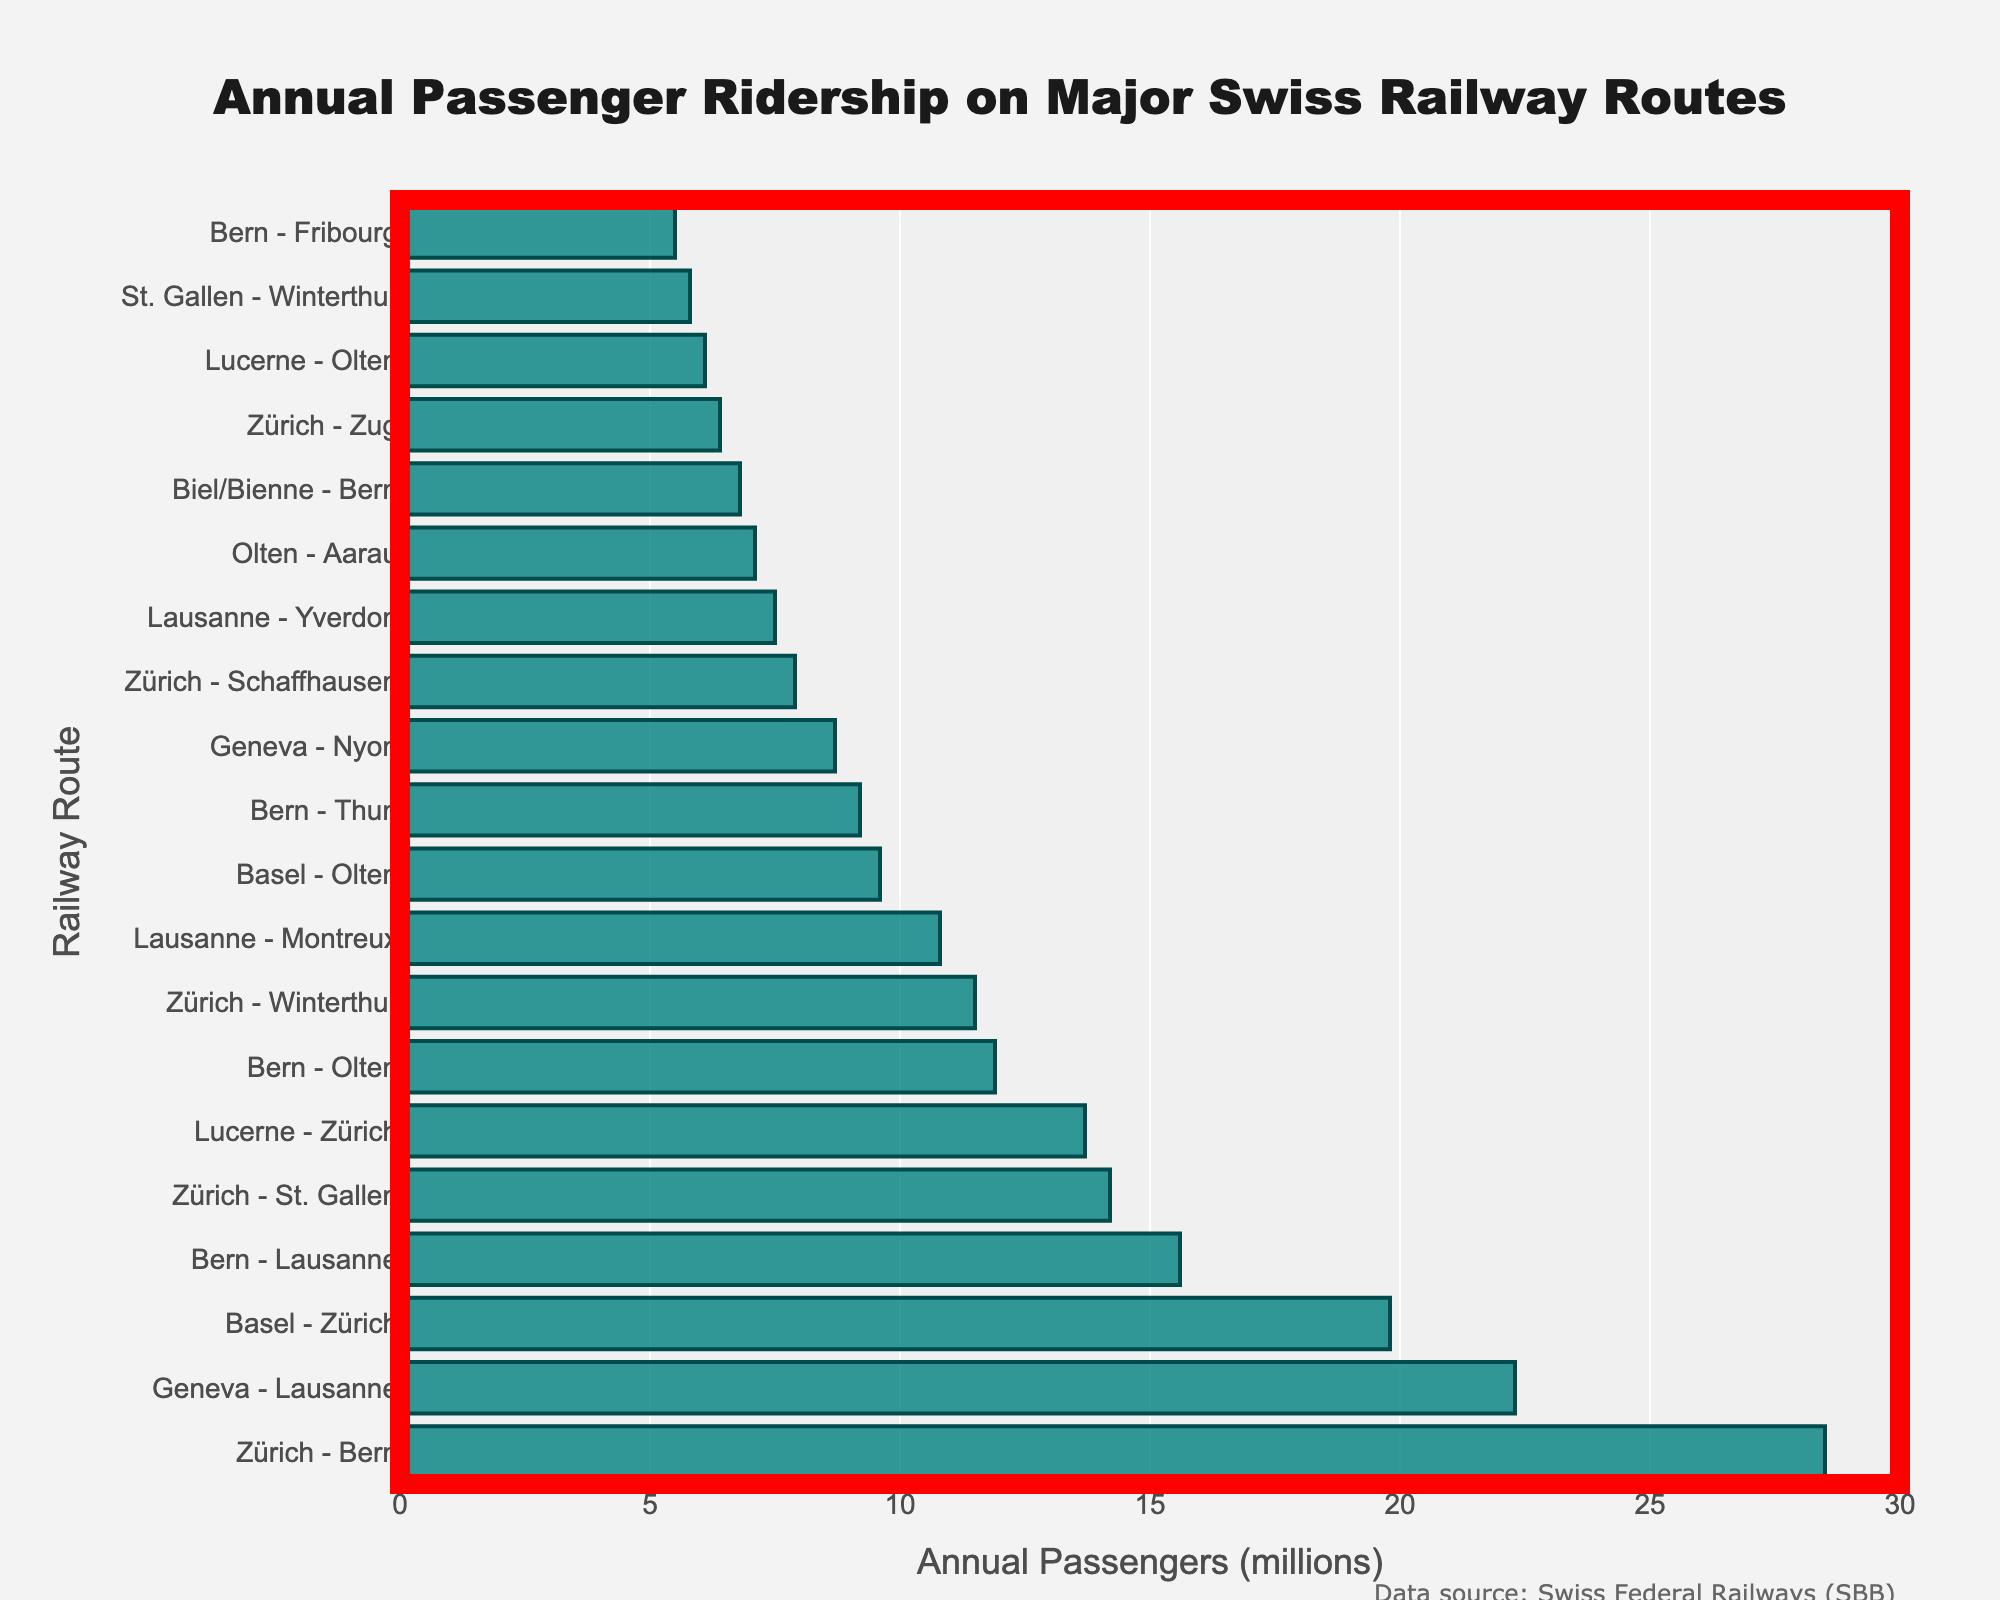What is the total number of annual passengers for the top three busiest routes combined? The top three busiest routes are Zürich - Bern (28.5 million), Geneva - Lausanne (22.3 million), and Basel - Zürich (19.8 million). Adding these values gives 28.5 + 22.3 + 19.8 = 70.6 million.
Answer: 70.6 million Which has more annual passengers, the route Zürich - Winterthur or the route Zürich - Zug? The route Zürich - Winterthur has 11.5 million passengers, while the route Zürich - Zug has 6.4 million. Comparing these, Zürich - Winterthur has more passengers.
Answer: Zürich - Winterthur What is the difference in passenger count between the busiest route (Zürich - Bern) and the least busy route (Bern - Fribourg)? The busiest route is Zürich - Bern with 28.5 million passengers, and the least busy route is Bern - Fribourg with 5.5 million passengers. The difference is 28.5 - 5.5 = 23 million.
Answer: 23 million How many routes have an annual passenger count greater than 10 million? The routes with more than 10 million passengers are Zürich - Bern, Geneva - Lausanne, Basel - Zürich, Bern - Lausanne, Zürich - St. Gallen, Lucerne - Zürich, Bern - Olten, and Zürich - Winterthur, totaling 8 routes.
Answer: 8 routes Does the route Lucerne - Olten have more or fewer annual passengers compared to St. Gallen - Winterthur? Lucerne - Olten has 6.1 million passengers, whereas St. Gallen - Winterthur has 5.8 million passengers. Lucerne - Olten has more passengers.
Answer: more What is the combined annual passenger count of the routes starting in Lausanne (Geneva - Lausanne, Lausanne - Montreux, Lausanne - Yverdon)? The routes are Geneva - Lausanne (22.3 million), Lausanne - Montreux (10.8 million), and Lausanne - Yverdon (7.5 million). Adding them gives 22.3 + 10.8 + 7.5 = 40.6 million.
Answer: 40.6 million Which route has the fourth-highest passenger count? The fourth-highest passenger count is for the route Bern - Lausanne with 15.6 million passengers.
Answer: Bern - Lausanne Among the routes listed, which route has the median passenger count? Sorting the routes by passenger count, the median route is Zürich - Schaffhausen, which is in the middle position, with 7.9 million passengers.
Answer: Zürich - Schaffhausen 